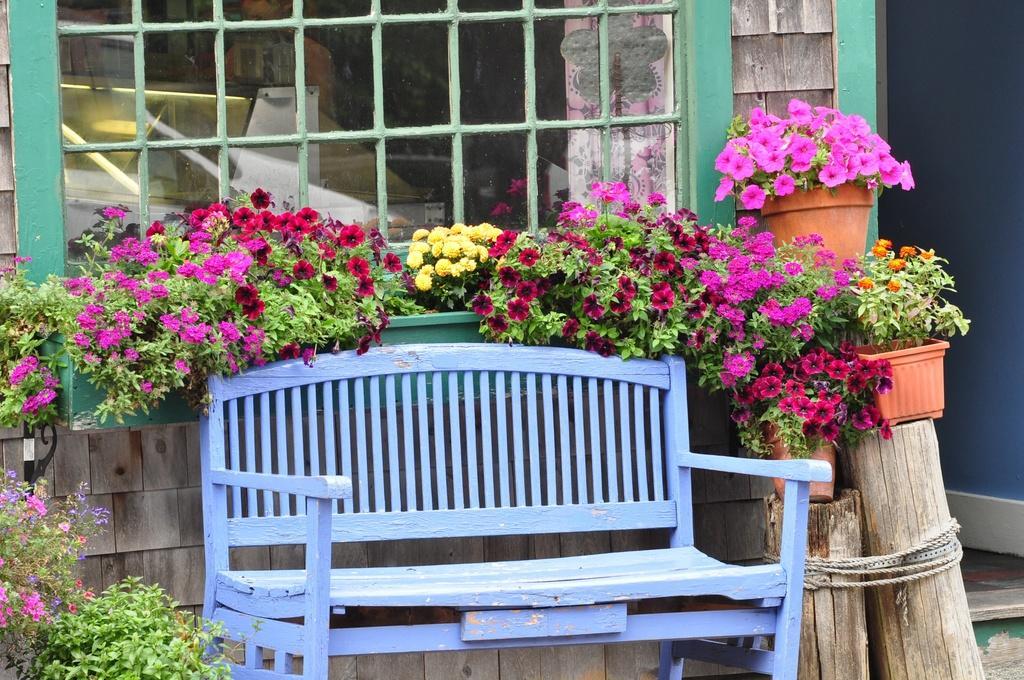How would you summarize this image in a sentence or two? This is a blue color wooden bench. These are the flower plants which are kept in the flower pot. This looks like a glass window. This is a wooden trunk tied up with a rope. 